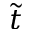Convert formula to latex. <formula><loc_0><loc_0><loc_500><loc_500>\tilde { t }</formula> 